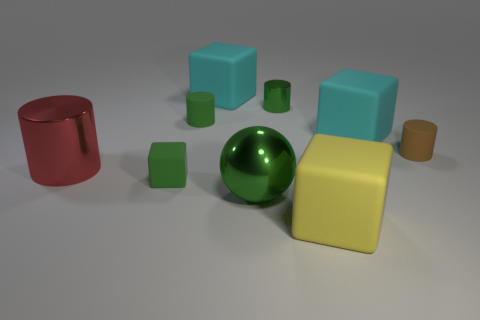There is a green cylinder that is left of the green metal thing that is in front of the large red cylinder; what is its size?
Offer a very short reply. Small. Is there another big yellow matte thing that has the same shape as the yellow thing?
Your answer should be compact. No. Do the cube in front of the big green metallic sphere and the green rubber thing right of the green block have the same size?
Provide a succinct answer. No. Is the number of big red metal cylinders to the left of the red cylinder less than the number of yellow things on the left side of the green rubber cylinder?
Make the answer very short. No. There is a large ball that is the same color as the tiny block; what is it made of?
Ensure brevity in your answer.  Metal. What color is the metallic thing that is to the right of the ball?
Ensure brevity in your answer.  Green. Do the large ball and the large shiny cylinder have the same color?
Your response must be concise. No. There is a small rubber cylinder that is behind the small matte thing that is to the right of the yellow block; how many big rubber blocks are behind it?
Your answer should be very brief. 1. How big is the green ball?
Provide a succinct answer. Large. There is a green block that is the same size as the brown matte thing; what material is it?
Your response must be concise. Rubber. 